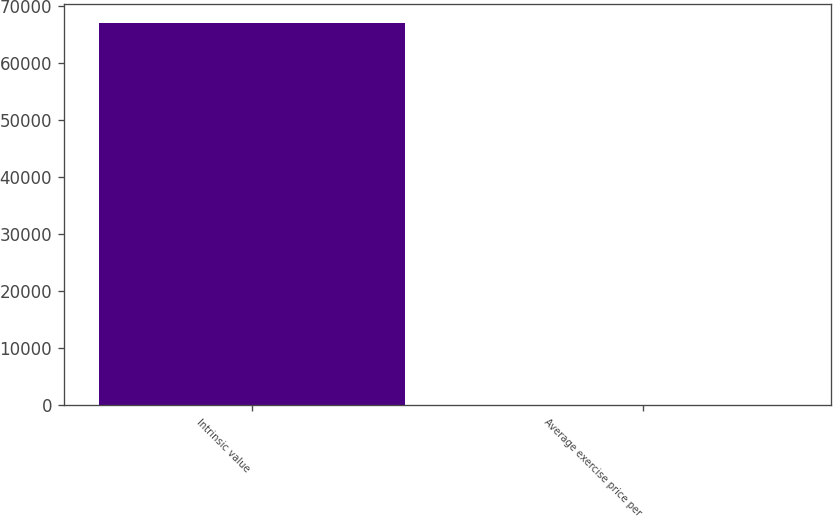Convert chart. <chart><loc_0><loc_0><loc_500><loc_500><bar_chart><fcel>Intrinsic value<fcel>Average exercise price per<nl><fcel>67089<fcel>34.56<nl></chart> 